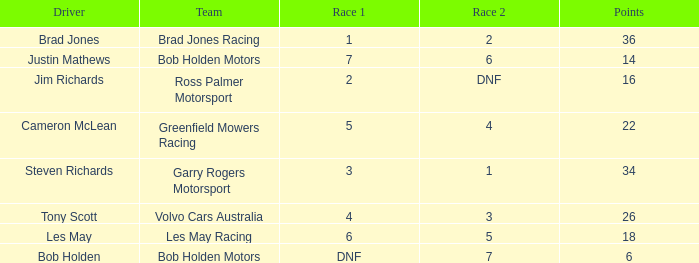Among bob holden motors' drivers, who has under 36 points and came in 7th place during the initial race? Justin Mathews. 